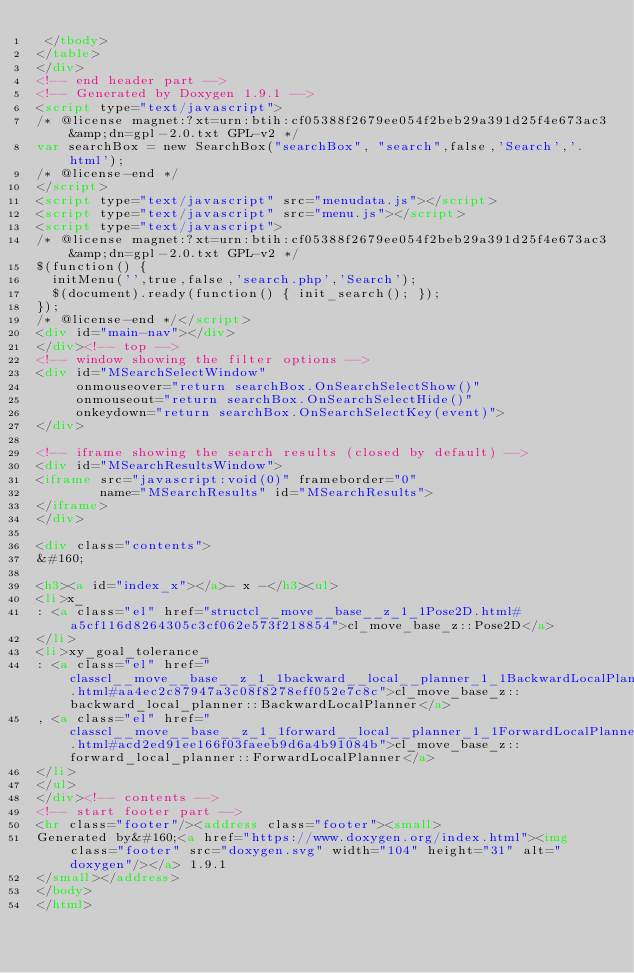Convert code to text. <code><loc_0><loc_0><loc_500><loc_500><_HTML_> </tbody>
</table>
</div>
<!-- end header part -->
<!-- Generated by Doxygen 1.9.1 -->
<script type="text/javascript">
/* @license magnet:?xt=urn:btih:cf05388f2679ee054f2beb29a391d25f4e673ac3&amp;dn=gpl-2.0.txt GPL-v2 */
var searchBox = new SearchBox("searchBox", "search",false,'Search','.html');
/* @license-end */
</script>
<script type="text/javascript" src="menudata.js"></script>
<script type="text/javascript" src="menu.js"></script>
<script type="text/javascript">
/* @license magnet:?xt=urn:btih:cf05388f2679ee054f2beb29a391d25f4e673ac3&amp;dn=gpl-2.0.txt GPL-v2 */
$(function() {
  initMenu('',true,false,'search.php','Search');
  $(document).ready(function() { init_search(); });
});
/* @license-end */</script>
<div id="main-nav"></div>
</div><!-- top -->
<!-- window showing the filter options -->
<div id="MSearchSelectWindow"
     onmouseover="return searchBox.OnSearchSelectShow()"
     onmouseout="return searchBox.OnSearchSelectHide()"
     onkeydown="return searchBox.OnSearchSelectKey(event)">
</div>

<!-- iframe showing the search results (closed by default) -->
<div id="MSearchResultsWindow">
<iframe src="javascript:void(0)" frameborder="0" 
        name="MSearchResults" id="MSearchResults">
</iframe>
</div>

<div class="contents">
&#160;

<h3><a id="index_x"></a>- x -</h3><ul>
<li>x_
: <a class="el" href="structcl__move__base__z_1_1Pose2D.html#a5cf116d8264305c3cf062e573f218854">cl_move_base_z::Pose2D</a>
</li>
<li>xy_goal_tolerance_
: <a class="el" href="classcl__move__base__z_1_1backward__local__planner_1_1BackwardLocalPlanner.html#aa4ec2c87947a3c08f8278eff052e7c8c">cl_move_base_z::backward_local_planner::BackwardLocalPlanner</a>
, <a class="el" href="classcl__move__base__z_1_1forward__local__planner_1_1ForwardLocalPlanner.html#acd2ed91ee166f03faeeb9d6a4b91084b">cl_move_base_z::forward_local_planner::ForwardLocalPlanner</a>
</li>
</ul>
</div><!-- contents -->
<!-- start footer part -->
<hr class="footer"/><address class="footer"><small>
Generated by&#160;<a href="https://www.doxygen.org/index.html"><img class="footer" src="doxygen.svg" width="104" height="31" alt="doxygen"/></a> 1.9.1
</small></address>
</body>
</html>
</code> 